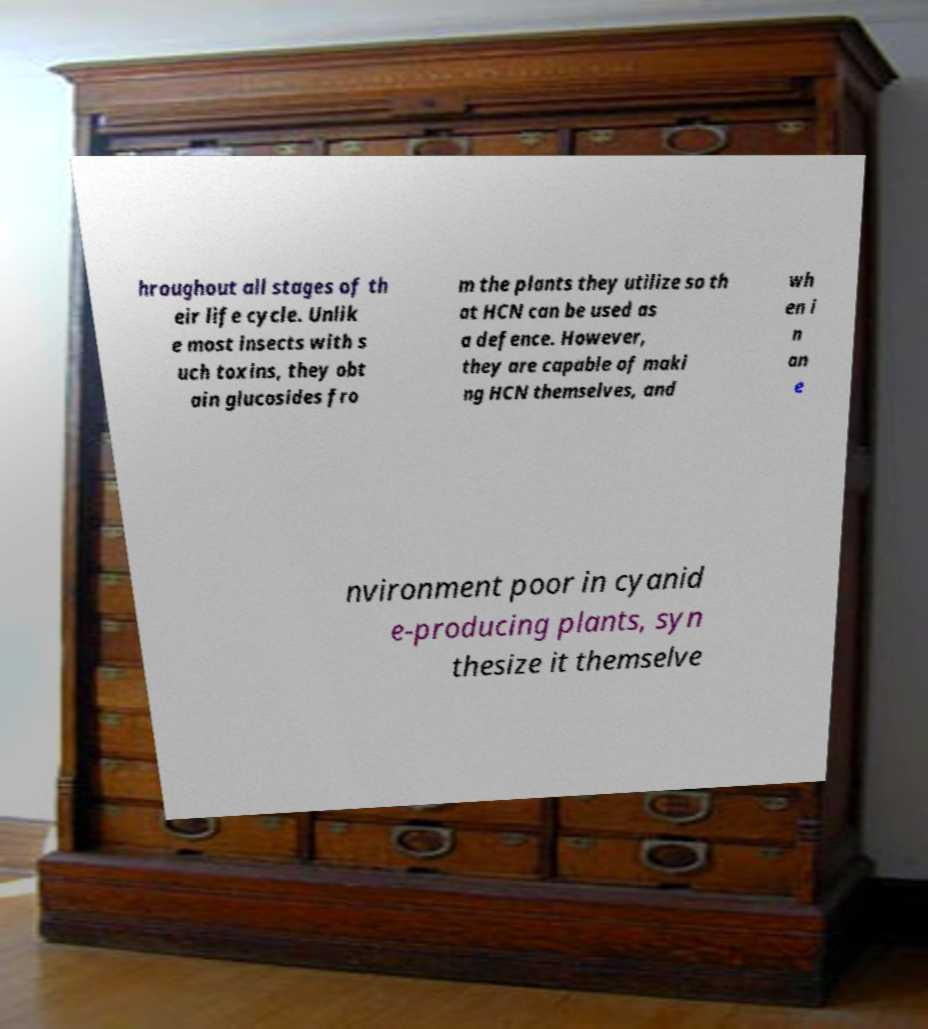What messages or text are displayed in this image? I need them in a readable, typed format. hroughout all stages of th eir life cycle. Unlik e most insects with s uch toxins, they obt ain glucosides fro m the plants they utilize so th at HCN can be used as a defence. However, they are capable of maki ng HCN themselves, and wh en i n an e nvironment poor in cyanid e-producing plants, syn thesize it themselve 